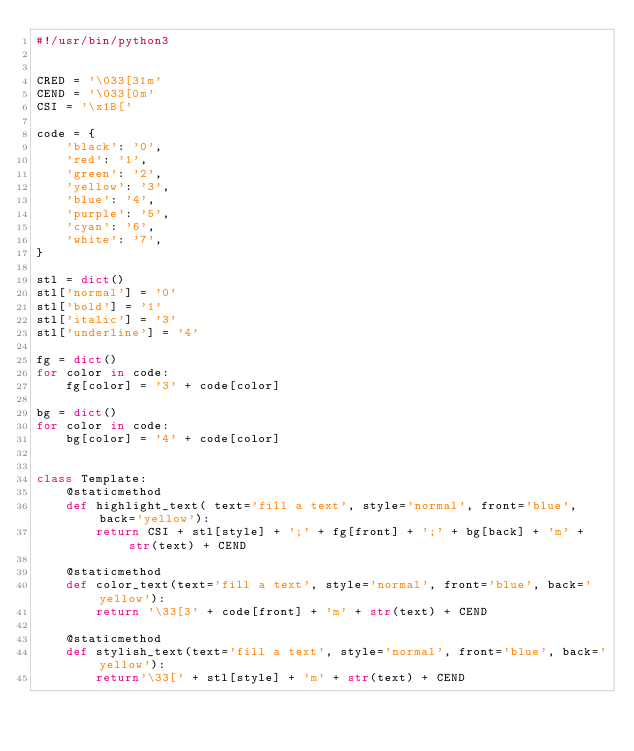<code> <loc_0><loc_0><loc_500><loc_500><_Python_>#!/usr/bin/python3


CRED = '\033[31m'
CEND = '\033[0m'
CSI = '\x1B['

code = {
    'black': '0',
    'red': '1',
    'green': '2',
    'yellow': '3',
    'blue': '4',
    'purple': '5',
    'cyan': '6',
    'white': '7',
}

stl = dict()
stl['normal'] = '0'
stl['bold'] = '1'
stl['italic'] = '3'
stl['underline'] = '4'

fg = dict()
for color in code:
    fg[color] = '3' + code[color]

bg = dict()
for color in code:
    bg[color] = '4' + code[color]


class Template:
    @staticmethod
    def highlight_text( text='fill a text', style='normal', front='blue', back='yellow'):
        return CSI + stl[style] + ';' + fg[front] + ';' + bg[back] + 'm' + str(text) + CEND
    
    @staticmethod
    def color_text(text='fill a text', style='normal', front='blue', back='yellow'):
        return '\33[3' + code[front] + 'm' + str(text) + CEND
    
    @staticmethod
    def stylish_text(text='fill a text', style='normal', front='blue', back='yellow'):
        return'\33[' + stl[style] + 'm' + str(text) + CEND
</code> 